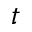<formula> <loc_0><loc_0><loc_500><loc_500>t</formula> 